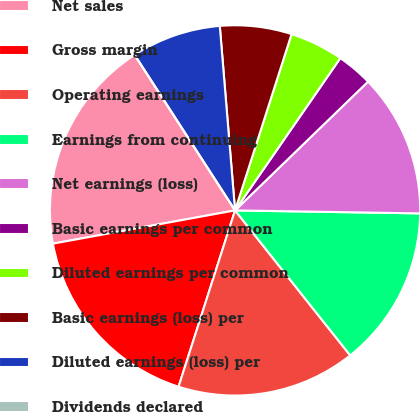Convert chart to OTSL. <chart><loc_0><loc_0><loc_500><loc_500><pie_chart><fcel>Net sales<fcel>Gross margin<fcel>Operating earnings<fcel>Earnings from continuing<fcel>Net earnings (loss)<fcel>Basic earnings per common<fcel>Diluted earnings per common<fcel>Basic earnings (loss) per<fcel>Diluted earnings (loss) per<fcel>Dividends declared<nl><fcel>18.75%<fcel>17.19%<fcel>15.62%<fcel>14.06%<fcel>12.5%<fcel>3.13%<fcel>4.69%<fcel>6.25%<fcel>7.81%<fcel>0.0%<nl></chart> 